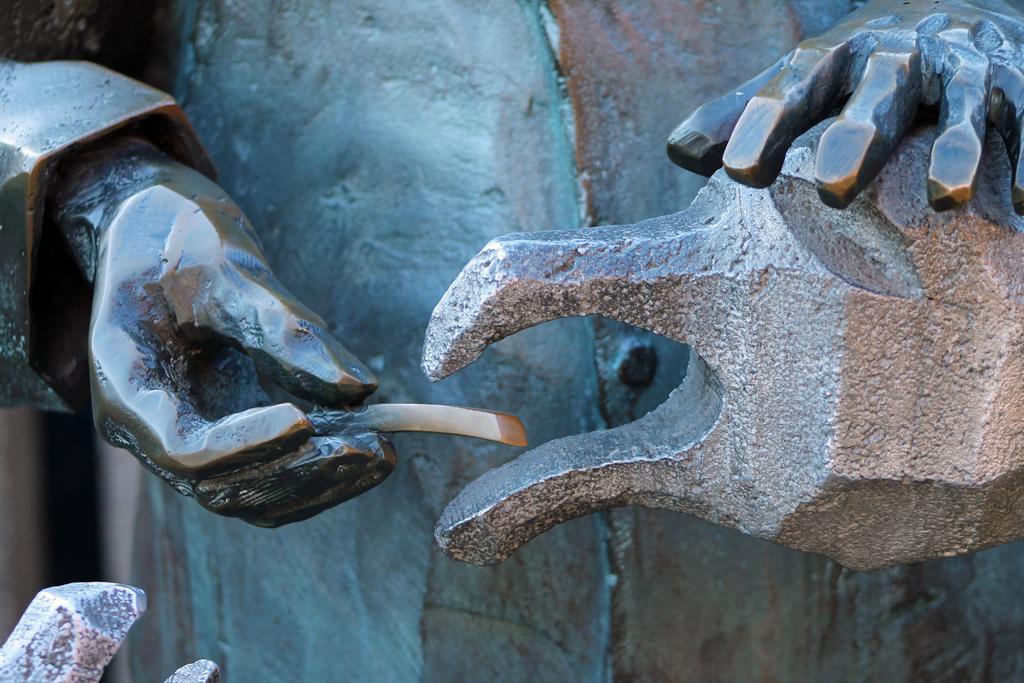In one or two sentences, can you explain what this image depicts? In this image there are statues. 